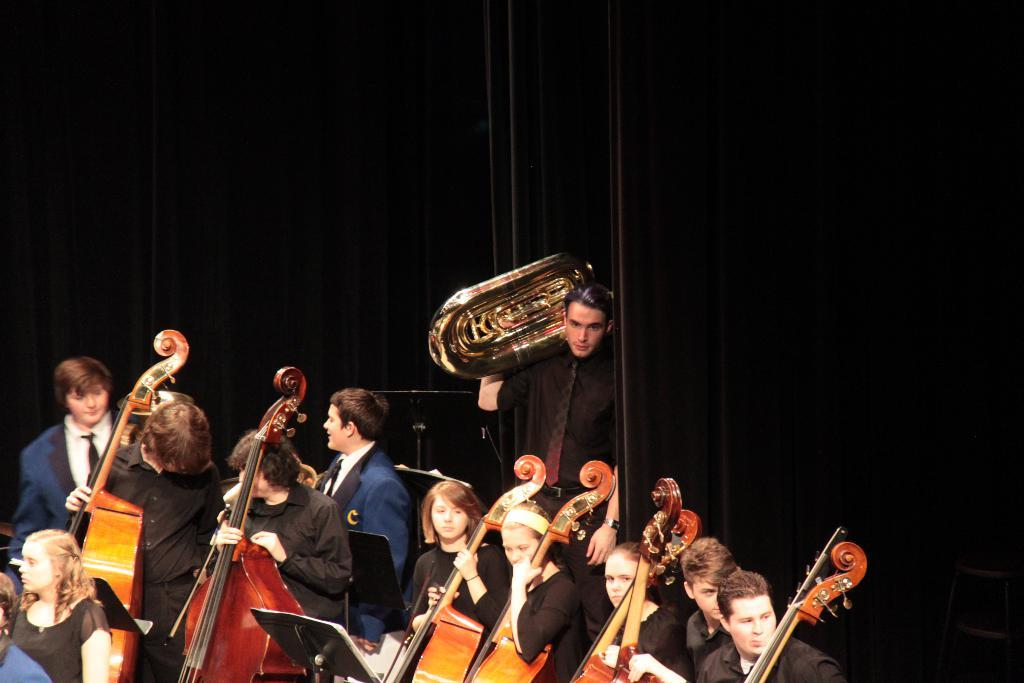What are the people in the image doing? The people in the image are playing musical instruments. What position are the people in while playing the instruments? The people are standing while playing the instruments. What else can be seen in the image besides the people playing instruments? There is a curtain visible in the image. What type of airport can be seen in the image? There is no airport present in the image; it features people playing musical instruments and a curtain. 